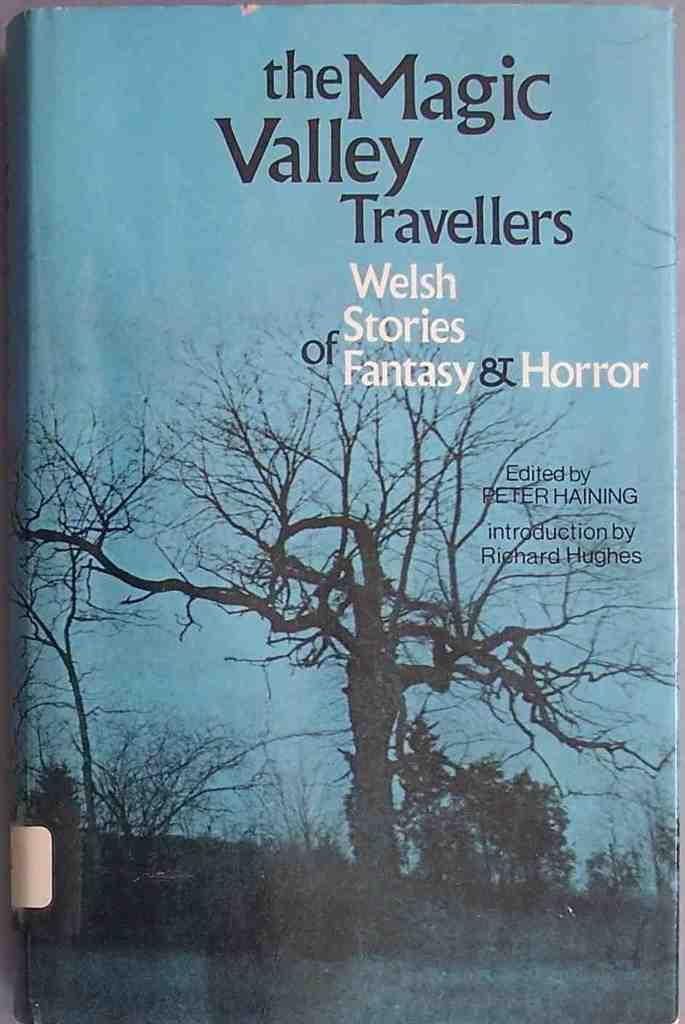<image>
Give a short and clear explanation of the subsequent image. A book called the Magic Valley Travellers that has Welsh stories of Fantasy and Horror.. 